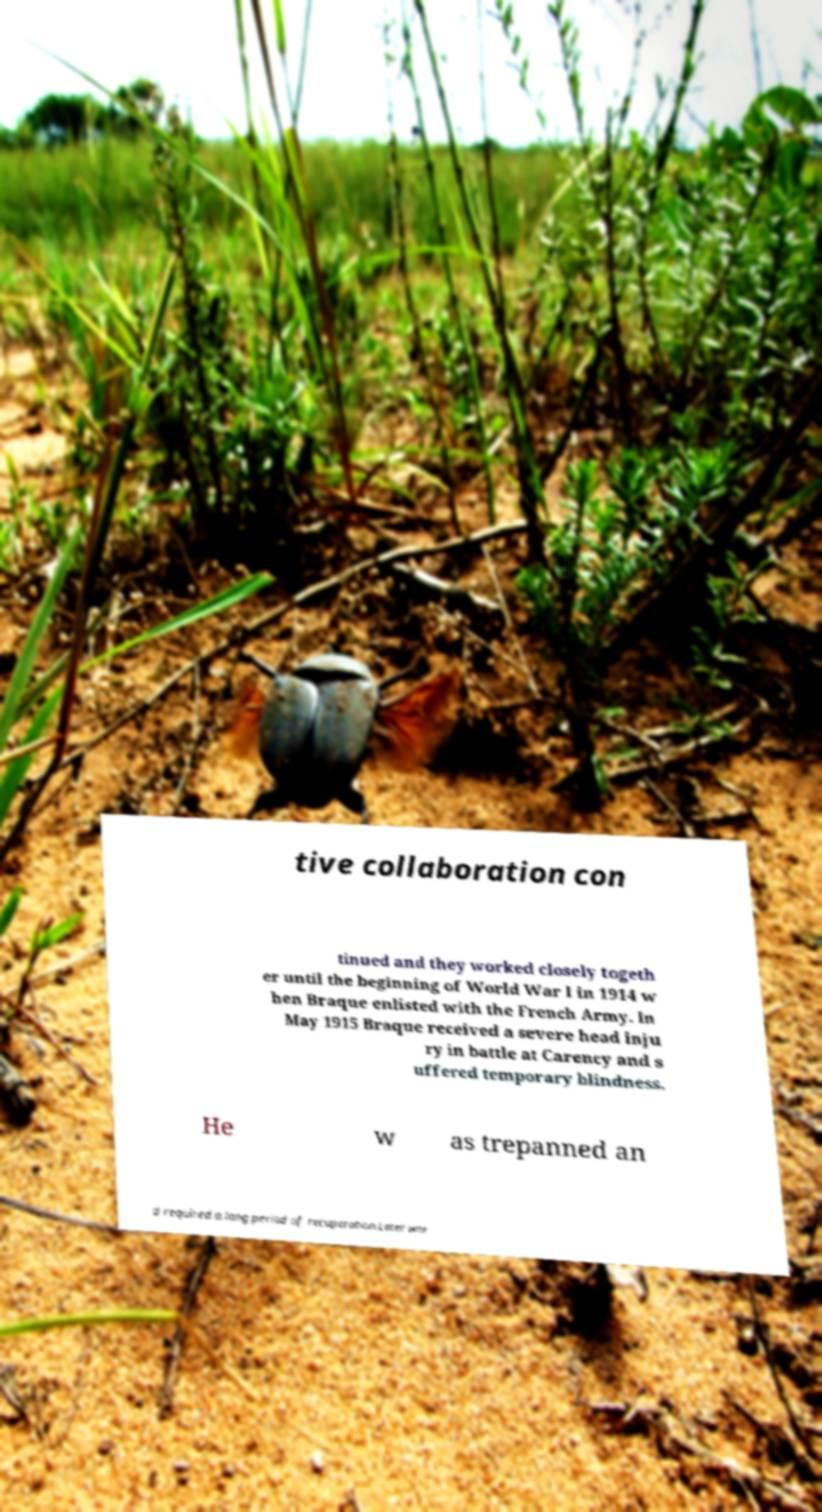Please identify and transcribe the text found in this image. tive collaboration con tinued and they worked closely togeth er until the beginning of World War I in 1914 w hen Braque enlisted with the French Army. In May 1915 Braque received a severe head inju ry in battle at Carency and s uffered temporary blindness. He w as trepanned an d required a long period of recuperation.Later wor 